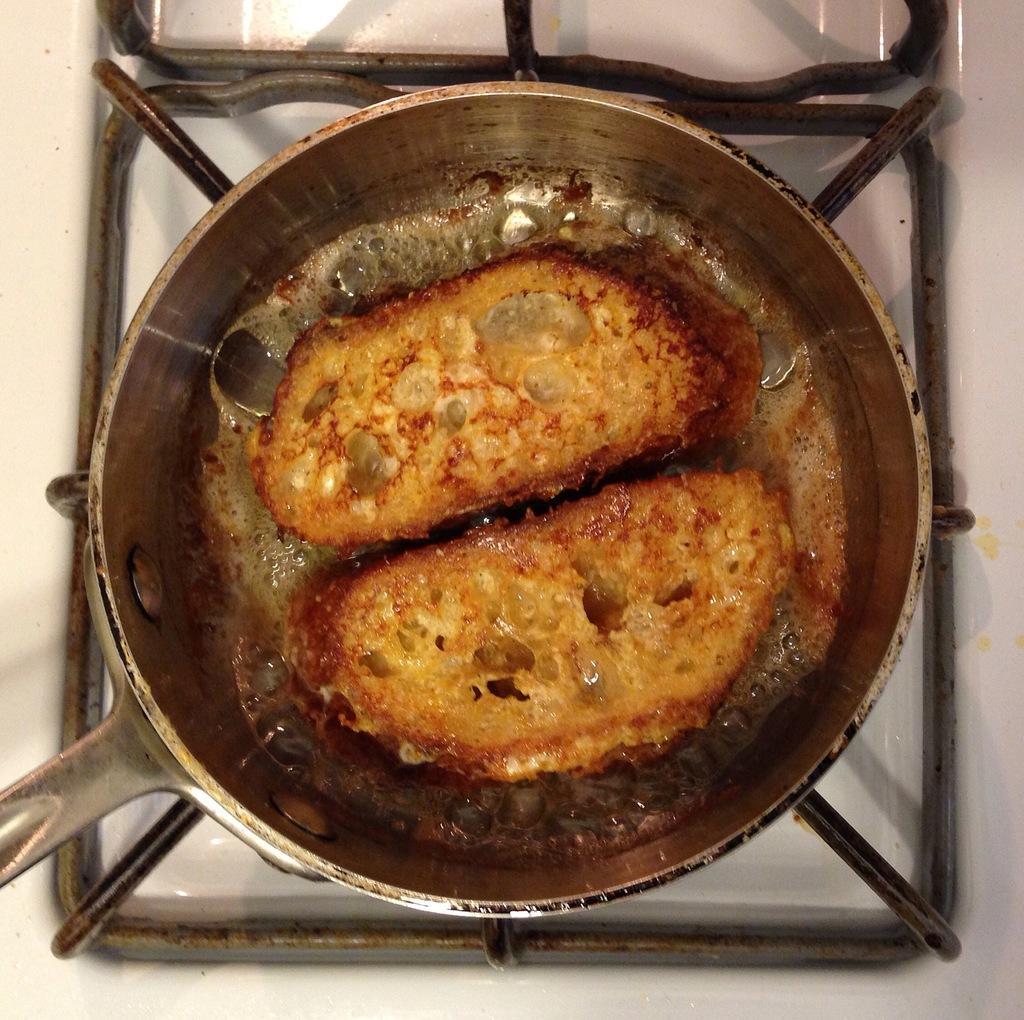In one or two sentences, can you explain what this image depicts? In this image there is a food item placed on the pan, which is on the stove. 